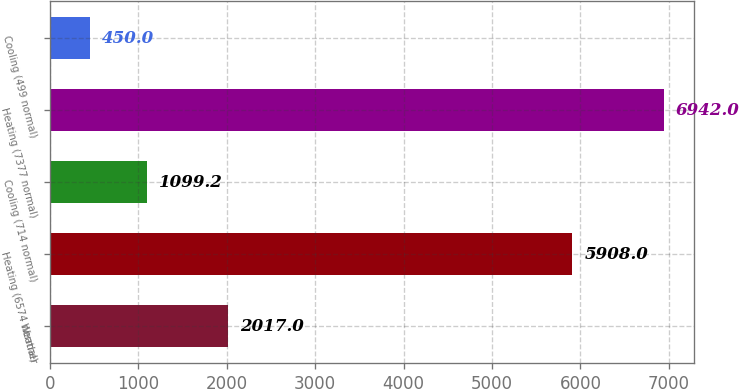Convert chart to OTSL. <chart><loc_0><loc_0><loc_500><loc_500><bar_chart><fcel>Weather<fcel>Heating (6574 normal)<fcel>Cooling (714 normal)<fcel>Heating (7377 normal)<fcel>Cooling (499 normal)<nl><fcel>2017<fcel>5908<fcel>1099.2<fcel>6942<fcel>450<nl></chart> 